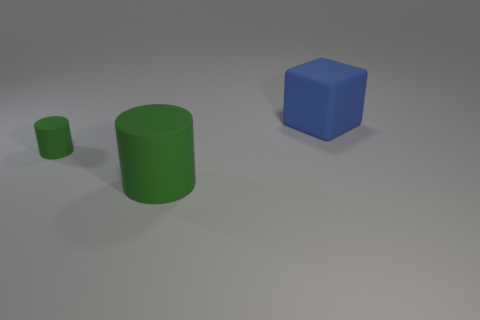What is the material of the large thing in front of the big matte thing behind the big thing that is left of the matte block?
Offer a very short reply. Rubber. There is a small object that is the same color as the large cylinder; what is it made of?
Your response must be concise. Rubber. How many things are either green cylinders or blue rubber objects?
Give a very brief answer. 3. Is the material of the green cylinder in front of the tiny green thing the same as the small green cylinder?
Keep it short and to the point. Yes. How many things are green things right of the small cylinder or blue cubes?
Your answer should be compact. 2. What color is the big cylinder that is the same material as the large block?
Give a very brief answer. Green. Is there a purple ball that has the same size as the blue thing?
Provide a short and direct response. No. There is a large rubber thing behind the tiny green cylinder; is its color the same as the small cylinder?
Offer a terse response. No. What color is the thing that is to the right of the tiny rubber thing and behind the large cylinder?
Your answer should be compact. Blue. What shape is the other matte object that is the same size as the blue rubber thing?
Give a very brief answer. Cylinder. 